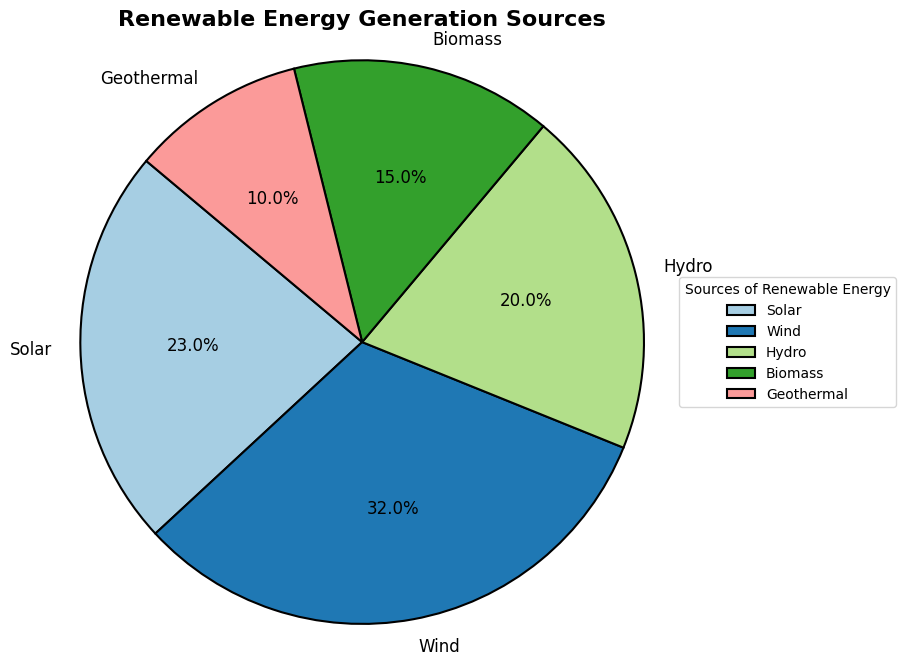Which source generates the highest percentage of renewable energy? By observing the figure, identify the sector with the largest slice. The slice labeled "Wind" is the largest.
Answer: Wind Compare the renewable energy generation percentages of Solar and Biomass. Locate the "Solar" and "Biomass" sectors in the chart. Solar has a 23% share while Biomass has a 15% share.
Answer: Solar generates more than Biomass Which two sources combined generate the same percentage of renewable energy as Wind alone? Wind accounts for 32% of the renewable energy. Find two sources whose percentages sum up to 32%. Solar (23%) and Geothermal (10%) together make 33%, which is less than Wind's percentage; whereas Solar (23%) and Hydro (20%) sum up to 43%, which is more. Biomass (15%) and Geothermal (10%) together sum 25%, hence they also don’t work. The correct pair is Hydro (20%) and Biomass (15%) that sums up to 35%, still higher than the value. The operation needs trial and considering the available options to check.
Answer: No exact match What is the visual angle difference between the slices representing Biomass and Hydro? Observe the chart, where Biomass accounts for 15% and Hydro represents 20%, resulting in a 5% visual difference. Each 1% sector near the center forms around 3.6-degree angle (360 degrees/100%). Multiply the percentage difference by this value (5*3.6).
Answer: The visual difference is approximately 18 degrees What is the percentage difference between Solar and Geothermal energy sources? Solar accounts for 23% and Geothermal accounts for 10% of energy sources. Subtract 10% from 23% to find the percentage difference.
Answer: 13% Which energy source contributes more, Biomass or Geothermal? Compare the sizes of the slices labeled "Biomass" and "Geothermal". Biomass has a larger slice.
Answer: Biomass Rank the energy sources from highest to lowest share. Compare all the slices visually and rank them based on their size: Wind, Solar, Hydro, Biomass, Geothermal.
Answer: Wind, Solar, Hydro, Biomass, Geothermal 